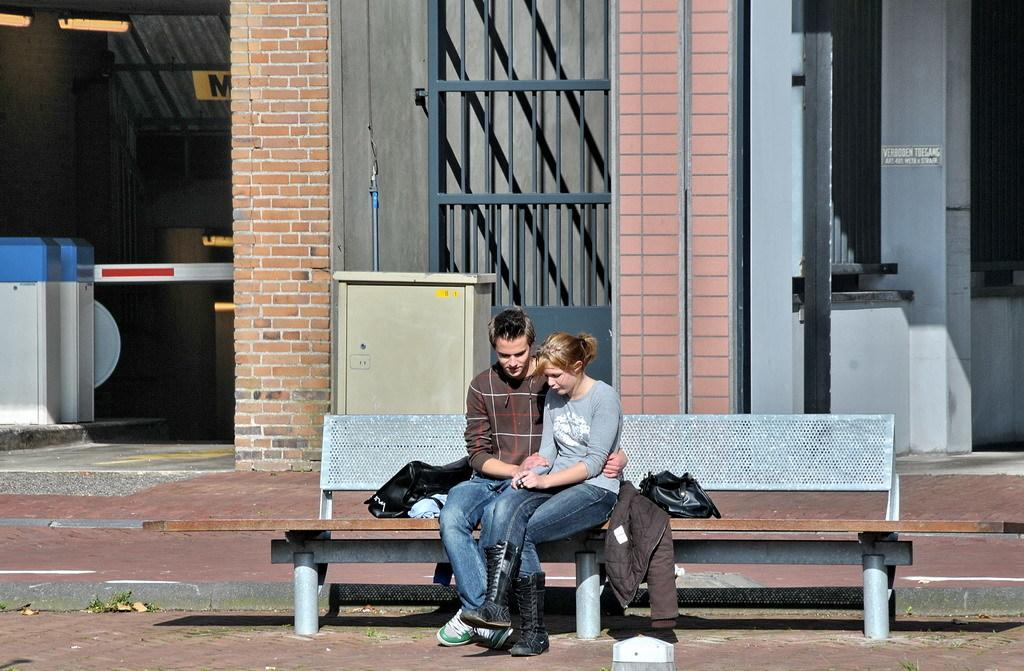How many people are in the image? There are two people in the image, a man and a woman. What are the man and woman doing in the image? Both the man and woman are sitting on a bench. What can be seen in the background of the image? There is a red wall and an iron gate in the background of the image. What items are visible on the people in the image? There is a handbag visible on the woman and a jacket visible on the man. What type of insect can be seen crawling on the man's jacket in the image? There is no insect visible on the man's jacket in the image. What is the connection between the man and woman in the image? The provided facts do not give any information about the relationship between the man and woman in the image. 